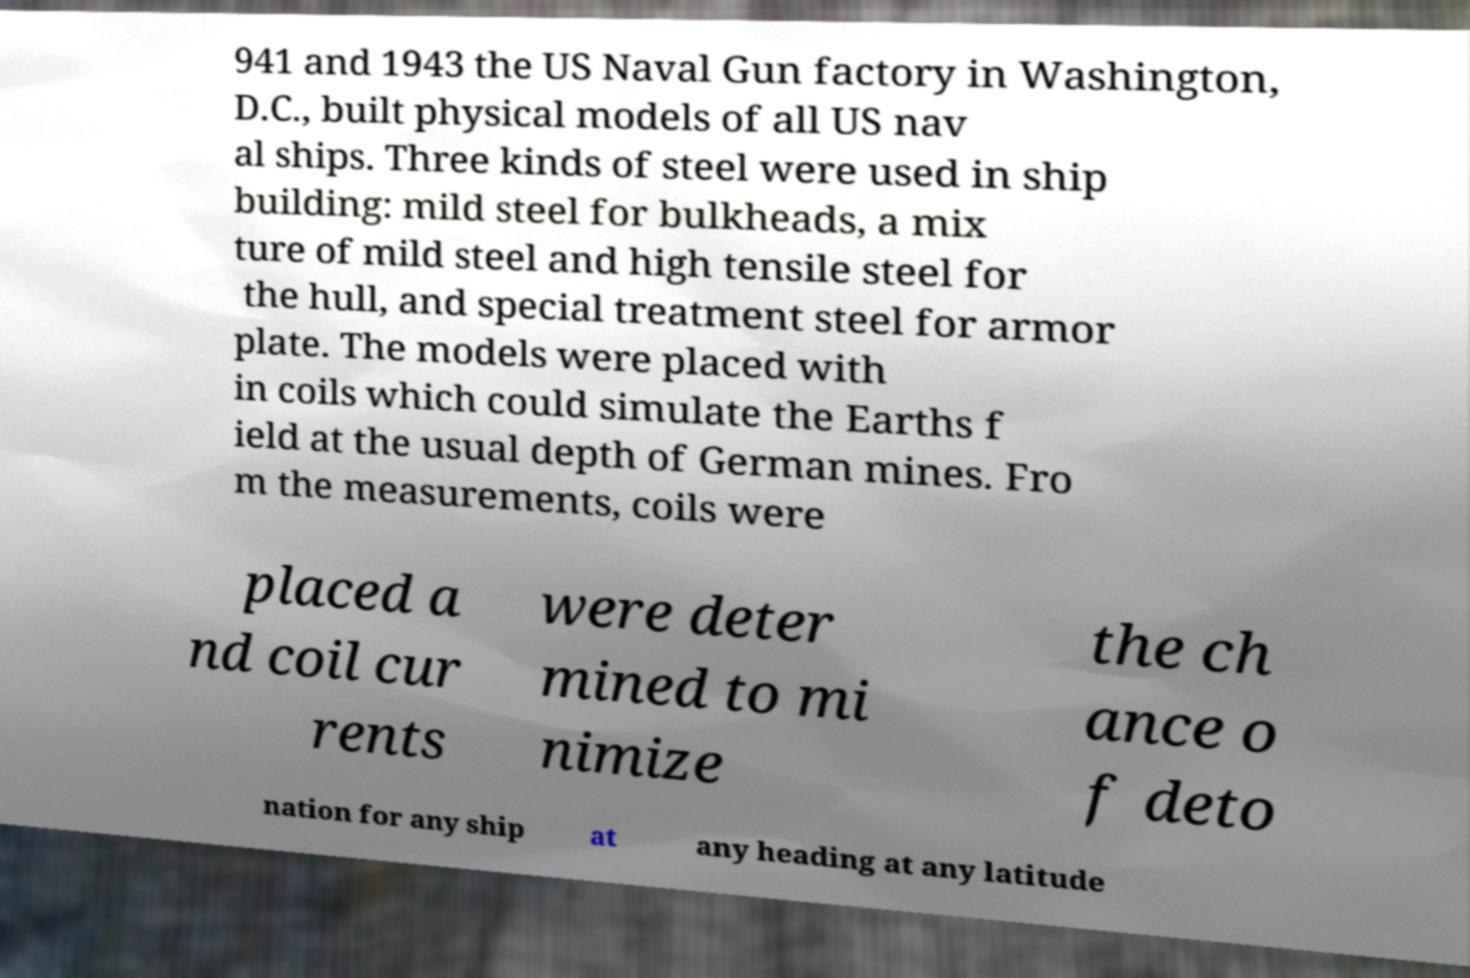Please read and relay the text visible in this image. What does it say? 941 and 1943 the US Naval Gun factory in Washington, D.C., built physical models of all US nav al ships. Three kinds of steel were used in ship building: mild steel for bulkheads, a mix ture of mild steel and high tensile steel for the hull, and special treatment steel for armor plate. The models were placed with in coils which could simulate the Earths f ield at the usual depth of German mines. Fro m the measurements, coils were placed a nd coil cur rents were deter mined to mi nimize the ch ance o f deto nation for any ship at any heading at any latitude 